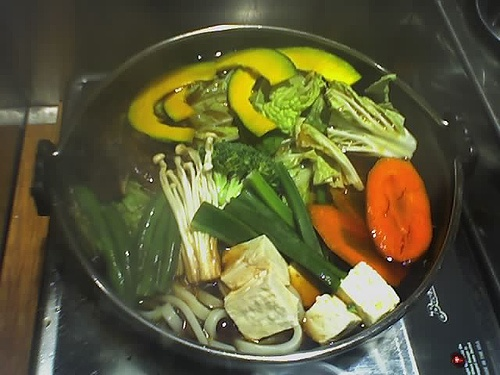Describe the objects in this image and their specific colors. I can see bowl in black, darkgreen, and olive tones, broccoli in black, olive, and khaki tones, carrot in black, red, brown, and maroon tones, carrot in black, maroon, brown, and red tones, and broccoli in black, darkgreen, lightgreen, and olive tones in this image. 